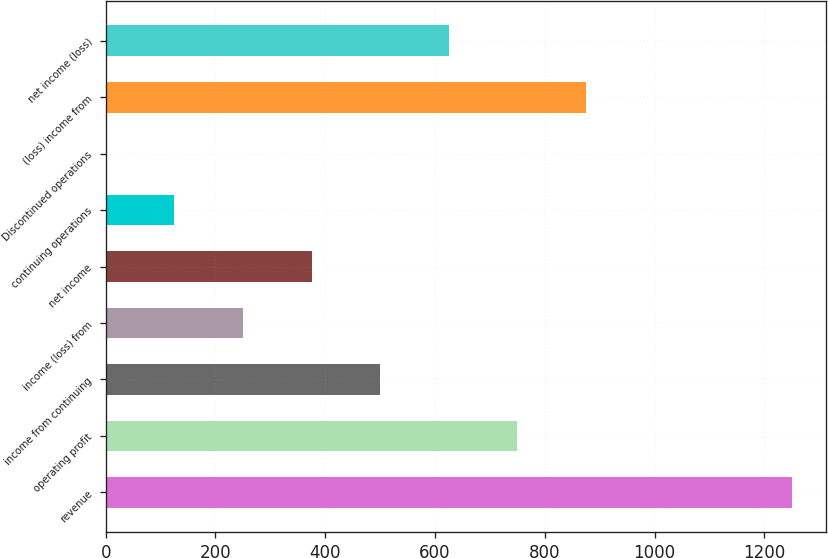<chart> <loc_0><loc_0><loc_500><loc_500><bar_chart><fcel>revenue<fcel>operating profit<fcel>income from continuing<fcel>income (loss) from<fcel>net income<fcel>continuing operations<fcel>Discontinued operations<fcel>(loss) income from<fcel>net income (loss)<nl><fcel>1250<fcel>750.01<fcel>500.01<fcel>250.01<fcel>375.01<fcel>125.01<fcel>0.01<fcel>875.01<fcel>625.01<nl></chart> 